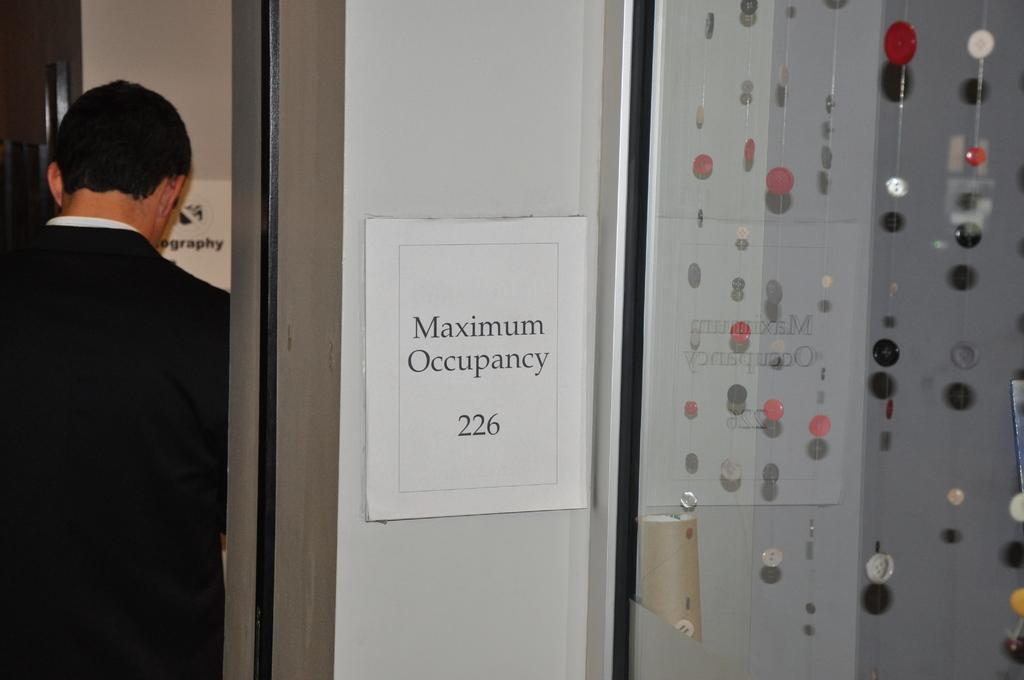How would you summarize this image in a sentence or two? In the foreground of this image, on the right, there are series of buttons hanging inside the glass and a cardboard roll inside it. In the middle, there is a poster on the wall. On the left, there is a man, wall and a poster. 